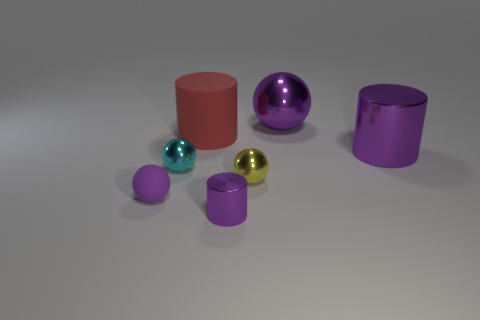Is the size of the purple rubber sphere the same as the purple ball that is behind the red rubber thing?
Provide a succinct answer. No. There is a big cylinder behind the shiny cylinder behind the tiny purple rubber thing; what is its material?
Your response must be concise. Rubber. Are there the same number of small yellow metal objects left of the tiny matte ball and big purple metallic spheres?
Provide a succinct answer. No. What size is the purple thing that is both in front of the large purple shiny ball and behind the tiny yellow object?
Ensure brevity in your answer.  Large. There is a metal object in front of the rubber thing that is to the left of the tiny cyan metal thing; what is its color?
Offer a very short reply. Purple. How many cyan objects are small metallic cylinders or small matte balls?
Offer a very short reply. 0. The metal thing that is both in front of the large rubber cylinder and behind the tiny cyan thing is what color?
Provide a short and direct response. Purple. How many small objects are either cylinders or yellow metallic balls?
Keep it short and to the point. 2. The yellow metal thing that is the same shape as the cyan object is what size?
Your answer should be compact. Small. The small yellow shiny object has what shape?
Your answer should be compact. Sphere. 